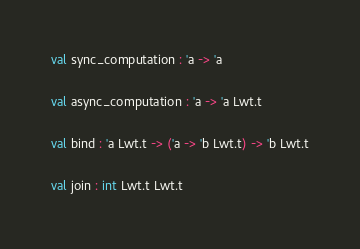<code> <loc_0><loc_0><loc_500><loc_500><_OCaml_>val sync_computation : 'a -> 'a

val async_computation : 'a -> 'a Lwt.t

val bind : 'a Lwt.t -> ('a -> 'b Lwt.t) -> 'b Lwt.t

val join : int Lwt.t Lwt.t
</code> 